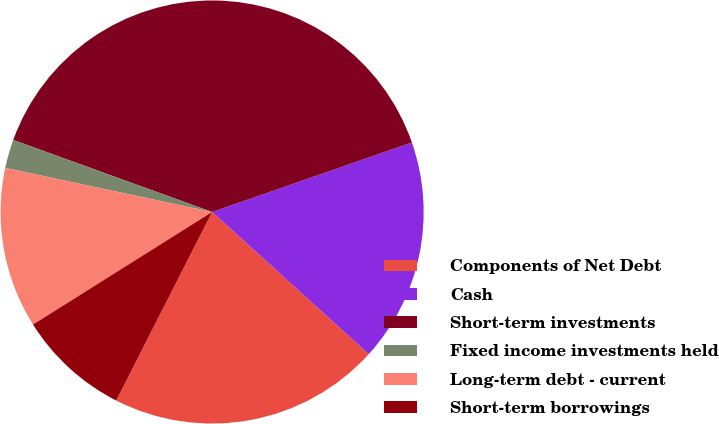Convert chart to OTSL. <chart><loc_0><loc_0><loc_500><loc_500><pie_chart><fcel>Components of Net Debt<fcel>Cash<fcel>Short-term investments<fcel>Fixed income investments held<fcel>Long-term debt - current<fcel>Short-term borrowings<nl><fcel>20.76%<fcel>17.06%<fcel>39.13%<fcel>2.19%<fcel>12.27%<fcel>8.58%<nl></chart> 